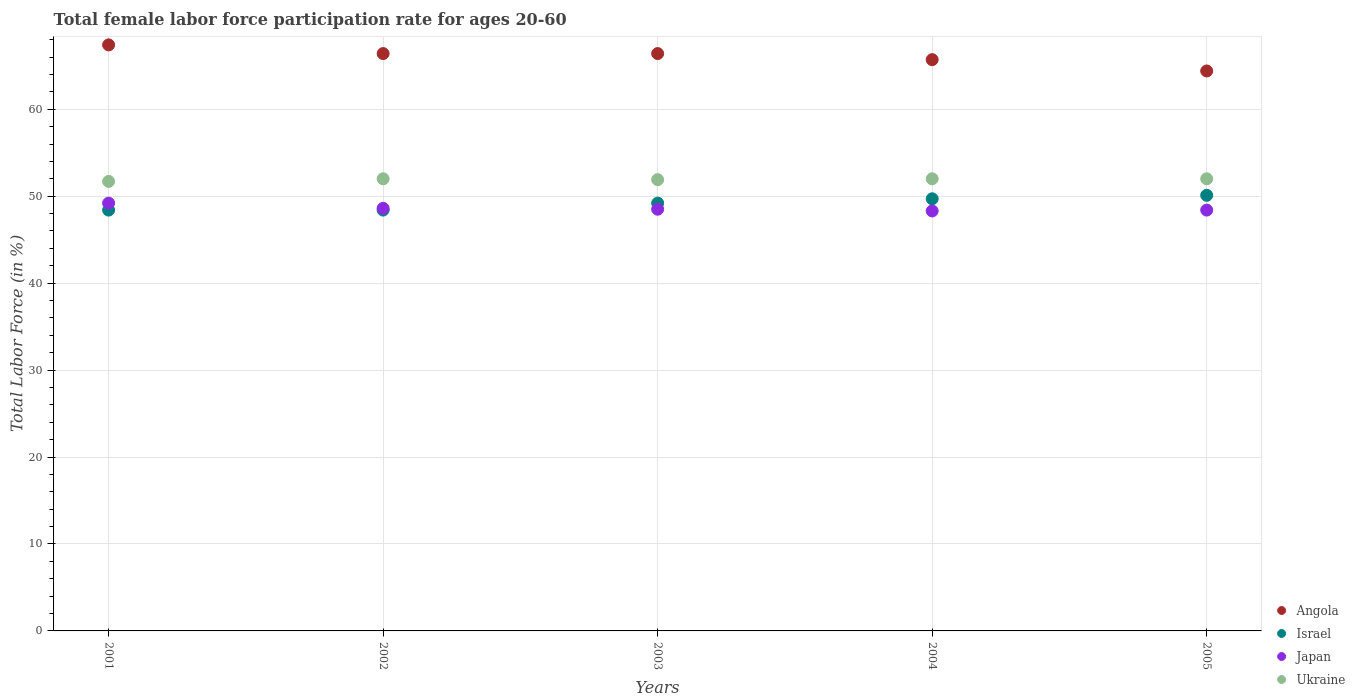How many different coloured dotlines are there?
Keep it short and to the point. 4. Is the number of dotlines equal to the number of legend labels?
Ensure brevity in your answer.  Yes. What is the female labor force participation rate in Angola in 2004?
Keep it short and to the point. 65.7. Across all years, what is the maximum female labor force participation rate in Angola?
Keep it short and to the point. 67.4. Across all years, what is the minimum female labor force participation rate in Japan?
Your response must be concise. 48.3. What is the total female labor force participation rate in Japan in the graph?
Give a very brief answer. 243. What is the average female labor force participation rate in Israel per year?
Keep it short and to the point. 49.16. In the year 2002, what is the difference between the female labor force participation rate in Israel and female labor force participation rate in Angola?
Offer a very short reply. -18. In how many years, is the female labor force participation rate in Israel greater than 60 %?
Your response must be concise. 0. What is the ratio of the female labor force participation rate in Israel in 2002 to that in 2004?
Keep it short and to the point. 0.97. Is the difference between the female labor force participation rate in Israel in 2004 and 2005 greater than the difference between the female labor force participation rate in Angola in 2004 and 2005?
Offer a terse response. No. What is the difference between the highest and the lowest female labor force participation rate in Ukraine?
Give a very brief answer. 0.3. In how many years, is the female labor force participation rate in Ukraine greater than the average female labor force participation rate in Ukraine taken over all years?
Offer a very short reply. 3. Is the sum of the female labor force participation rate in Angola in 2004 and 2005 greater than the maximum female labor force participation rate in Israel across all years?
Make the answer very short. Yes. Does the female labor force participation rate in Japan monotonically increase over the years?
Provide a succinct answer. No. Is the female labor force participation rate in Ukraine strictly greater than the female labor force participation rate in Angola over the years?
Keep it short and to the point. No. Does the graph contain any zero values?
Your answer should be very brief. No. How are the legend labels stacked?
Offer a terse response. Vertical. What is the title of the graph?
Give a very brief answer. Total female labor force participation rate for ages 20-60. Does "Monaco" appear as one of the legend labels in the graph?
Offer a terse response. No. What is the label or title of the Y-axis?
Provide a short and direct response. Total Labor Force (in %). What is the Total Labor Force (in %) of Angola in 2001?
Provide a short and direct response. 67.4. What is the Total Labor Force (in %) of Israel in 2001?
Give a very brief answer. 48.4. What is the Total Labor Force (in %) in Japan in 2001?
Give a very brief answer. 49.2. What is the Total Labor Force (in %) of Ukraine in 2001?
Your answer should be very brief. 51.7. What is the Total Labor Force (in %) in Angola in 2002?
Ensure brevity in your answer.  66.4. What is the Total Labor Force (in %) in Israel in 2002?
Keep it short and to the point. 48.4. What is the Total Labor Force (in %) of Japan in 2002?
Provide a succinct answer. 48.6. What is the Total Labor Force (in %) of Ukraine in 2002?
Your answer should be very brief. 52. What is the Total Labor Force (in %) in Angola in 2003?
Your response must be concise. 66.4. What is the Total Labor Force (in %) of Israel in 2003?
Your answer should be very brief. 49.2. What is the Total Labor Force (in %) in Japan in 2003?
Your response must be concise. 48.5. What is the Total Labor Force (in %) in Ukraine in 2003?
Provide a short and direct response. 51.9. What is the Total Labor Force (in %) in Angola in 2004?
Give a very brief answer. 65.7. What is the Total Labor Force (in %) of Israel in 2004?
Offer a very short reply. 49.7. What is the Total Labor Force (in %) in Japan in 2004?
Offer a terse response. 48.3. What is the Total Labor Force (in %) of Angola in 2005?
Offer a terse response. 64.4. What is the Total Labor Force (in %) of Israel in 2005?
Provide a short and direct response. 50.1. What is the Total Labor Force (in %) in Japan in 2005?
Offer a very short reply. 48.4. What is the Total Labor Force (in %) in Ukraine in 2005?
Offer a terse response. 52. Across all years, what is the maximum Total Labor Force (in %) of Angola?
Your answer should be compact. 67.4. Across all years, what is the maximum Total Labor Force (in %) in Israel?
Make the answer very short. 50.1. Across all years, what is the maximum Total Labor Force (in %) of Japan?
Make the answer very short. 49.2. Across all years, what is the minimum Total Labor Force (in %) of Angola?
Offer a terse response. 64.4. Across all years, what is the minimum Total Labor Force (in %) in Israel?
Offer a very short reply. 48.4. Across all years, what is the minimum Total Labor Force (in %) of Japan?
Keep it short and to the point. 48.3. Across all years, what is the minimum Total Labor Force (in %) in Ukraine?
Give a very brief answer. 51.7. What is the total Total Labor Force (in %) of Angola in the graph?
Keep it short and to the point. 330.3. What is the total Total Labor Force (in %) in Israel in the graph?
Give a very brief answer. 245.8. What is the total Total Labor Force (in %) of Japan in the graph?
Ensure brevity in your answer.  243. What is the total Total Labor Force (in %) in Ukraine in the graph?
Give a very brief answer. 259.6. What is the difference between the Total Labor Force (in %) of Japan in 2001 and that in 2002?
Offer a terse response. 0.6. What is the difference between the Total Labor Force (in %) of Ukraine in 2001 and that in 2002?
Make the answer very short. -0.3. What is the difference between the Total Labor Force (in %) in Angola in 2001 and that in 2003?
Provide a short and direct response. 1. What is the difference between the Total Labor Force (in %) in Japan in 2001 and that in 2003?
Keep it short and to the point. 0.7. What is the difference between the Total Labor Force (in %) in Angola in 2001 and that in 2004?
Your response must be concise. 1.7. What is the difference between the Total Labor Force (in %) in Israel in 2001 and that in 2004?
Your response must be concise. -1.3. What is the difference between the Total Labor Force (in %) in Ukraine in 2001 and that in 2004?
Provide a succinct answer. -0.3. What is the difference between the Total Labor Force (in %) of Angola in 2002 and that in 2003?
Your answer should be very brief. 0. What is the difference between the Total Labor Force (in %) in Israel in 2002 and that in 2003?
Your answer should be very brief. -0.8. What is the difference between the Total Labor Force (in %) in Ukraine in 2002 and that in 2003?
Your answer should be very brief. 0.1. What is the difference between the Total Labor Force (in %) of Angola in 2002 and that in 2004?
Keep it short and to the point. 0.7. What is the difference between the Total Labor Force (in %) in Japan in 2002 and that in 2004?
Your answer should be very brief. 0.3. What is the difference between the Total Labor Force (in %) of Ukraine in 2002 and that in 2004?
Make the answer very short. 0. What is the difference between the Total Labor Force (in %) in Israel in 2002 and that in 2005?
Provide a succinct answer. -1.7. What is the difference between the Total Labor Force (in %) in Ukraine in 2002 and that in 2005?
Offer a terse response. 0. What is the difference between the Total Labor Force (in %) in Israel in 2003 and that in 2004?
Your answer should be compact. -0.5. What is the difference between the Total Labor Force (in %) of Japan in 2003 and that in 2004?
Provide a short and direct response. 0.2. What is the difference between the Total Labor Force (in %) in Ukraine in 2003 and that in 2004?
Provide a succinct answer. -0.1. What is the difference between the Total Labor Force (in %) of Angola in 2004 and that in 2005?
Give a very brief answer. 1.3. What is the difference between the Total Labor Force (in %) of Angola in 2001 and the Total Labor Force (in %) of Japan in 2002?
Ensure brevity in your answer.  18.8. What is the difference between the Total Labor Force (in %) in Angola in 2001 and the Total Labor Force (in %) in Ukraine in 2002?
Provide a short and direct response. 15.4. What is the difference between the Total Labor Force (in %) of Israel in 2001 and the Total Labor Force (in %) of Ukraine in 2002?
Your response must be concise. -3.6. What is the difference between the Total Labor Force (in %) of Japan in 2001 and the Total Labor Force (in %) of Ukraine in 2002?
Provide a succinct answer. -2.8. What is the difference between the Total Labor Force (in %) in Angola in 2001 and the Total Labor Force (in %) in Ukraine in 2003?
Make the answer very short. 15.5. What is the difference between the Total Labor Force (in %) of Israel in 2001 and the Total Labor Force (in %) of Ukraine in 2003?
Provide a short and direct response. -3.5. What is the difference between the Total Labor Force (in %) in Japan in 2001 and the Total Labor Force (in %) in Ukraine in 2003?
Keep it short and to the point. -2.7. What is the difference between the Total Labor Force (in %) of Angola in 2001 and the Total Labor Force (in %) of Israel in 2004?
Offer a terse response. 17.7. What is the difference between the Total Labor Force (in %) of Angola in 2001 and the Total Labor Force (in %) of Ukraine in 2004?
Give a very brief answer. 15.4. What is the difference between the Total Labor Force (in %) in Japan in 2001 and the Total Labor Force (in %) in Ukraine in 2004?
Provide a short and direct response. -2.8. What is the difference between the Total Labor Force (in %) of Angola in 2001 and the Total Labor Force (in %) of Japan in 2005?
Give a very brief answer. 19. What is the difference between the Total Labor Force (in %) of Israel in 2001 and the Total Labor Force (in %) of Ukraine in 2005?
Give a very brief answer. -3.6. What is the difference between the Total Labor Force (in %) of Angola in 2002 and the Total Labor Force (in %) of Israel in 2003?
Offer a very short reply. 17.2. What is the difference between the Total Labor Force (in %) of Angola in 2002 and the Total Labor Force (in %) of Japan in 2003?
Offer a terse response. 17.9. What is the difference between the Total Labor Force (in %) in Angola in 2002 and the Total Labor Force (in %) in Ukraine in 2003?
Make the answer very short. 14.5. What is the difference between the Total Labor Force (in %) of Israel in 2002 and the Total Labor Force (in %) of Ukraine in 2003?
Your response must be concise. -3.5. What is the difference between the Total Labor Force (in %) in Japan in 2002 and the Total Labor Force (in %) in Ukraine in 2003?
Your answer should be compact. -3.3. What is the difference between the Total Labor Force (in %) of Israel in 2002 and the Total Labor Force (in %) of Japan in 2004?
Offer a terse response. 0.1. What is the difference between the Total Labor Force (in %) in Israel in 2002 and the Total Labor Force (in %) in Ukraine in 2004?
Your response must be concise. -3.6. What is the difference between the Total Labor Force (in %) in Angola in 2002 and the Total Labor Force (in %) in Japan in 2005?
Your response must be concise. 18. What is the difference between the Total Labor Force (in %) in Angola in 2002 and the Total Labor Force (in %) in Ukraine in 2005?
Ensure brevity in your answer.  14.4. What is the difference between the Total Labor Force (in %) of Israel in 2002 and the Total Labor Force (in %) of Japan in 2005?
Make the answer very short. 0. What is the difference between the Total Labor Force (in %) of Angola in 2003 and the Total Labor Force (in %) of Israel in 2004?
Your response must be concise. 16.7. What is the difference between the Total Labor Force (in %) of Angola in 2003 and the Total Labor Force (in %) of Japan in 2004?
Provide a short and direct response. 18.1. What is the difference between the Total Labor Force (in %) of Angola in 2003 and the Total Labor Force (in %) of Ukraine in 2004?
Provide a succinct answer. 14.4. What is the difference between the Total Labor Force (in %) in Japan in 2003 and the Total Labor Force (in %) in Ukraine in 2004?
Keep it short and to the point. -3.5. What is the difference between the Total Labor Force (in %) of Angola in 2003 and the Total Labor Force (in %) of Japan in 2005?
Give a very brief answer. 18. What is the difference between the Total Labor Force (in %) in Angola in 2003 and the Total Labor Force (in %) in Ukraine in 2005?
Offer a terse response. 14.4. What is the difference between the Total Labor Force (in %) in Israel in 2003 and the Total Labor Force (in %) in Japan in 2005?
Offer a terse response. 0.8. What is the difference between the Total Labor Force (in %) in Angola in 2004 and the Total Labor Force (in %) in Japan in 2005?
Provide a succinct answer. 17.3. What is the difference between the Total Labor Force (in %) of Angola in 2004 and the Total Labor Force (in %) of Ukraine in 2005?
Provide a succinct answer. 13.7. What is the difference between the Total Labor Force (in %) of Israel in 2004 and the Total Labor Force (in %) of Japan in 2005?
Your answer should be compact. 1.3. What is the average Total Labor Force (in %) of Angola per year?
Make the answer very short. 66.06. What is the average Total Labor Force (in %) in Israel per year?
Your answer should be very brief. 49.16. What is the average Total Labor Force (in %) in Japan per year?
Your answer should be very brief. 48.6. What is the average Total Labor Force (in %) in Ukraine per year?
Provide a succinct answer. 51.92. In the year 2001, what is the difference between the Total Labor Force (in %) of Angola and Total Labor Force (in %) of Israel?
Offer a terse response. 19. In the year 2001, what is the difference between the Total Labor Force (in %) of Angola and Total Labor Force (in %) of Japan?
Provide a short and direct response. 18.2. In the year 2001, what is the difference between the Total Labor Force (in %) in Israel and Total Labor Force (in %) in Japan?
Offer a terse response. -0.8. In the year 2001, what is the difference between the Total Labor Force (in %) in Israel and Total Labor Force (in %) in Ukraine?
Give a very brief answer. -3.3. In the year 2001, what is the difference between the Total Labor Force (in %) in Japan and Total Labor Force (in %) in Ukraine?
Keep it short and to the point. -2.5. In the year 2002, what is the difference between the Total Labor Force (in %) of Angola and Total Labor Force (in %) of Israel?
Your answer should be compact. 18. In the year 2002, what is the difference between the Total Labor Force (in %) of Angola and Total Labor Force (in %) of Ukraine?
Provide a short and direct response. 14.4. In the year 2002, what is the difference between the Total Labor Force (in %) in Israel and Total Labor Force (in %) in Japan?
Ensure brevity in your answer.  -0.2. In the year 2002, what is the difference between the Total Labor Force (in %) in Israel and Total Labor Force (in %) in Ukraine?
Provide a short and direct response. -3.6. In the year 2002, what is the difference between the Total Labor Force (in %) in Japan and Total Labor Force (in %) in Ukraine?
Offer a terse response. -3.4. In the year 2003, what is the difference between the Total Labor Force (in %) of Angola and Total Labor Force (in %) of Israel?
Offer a very short reply. 17.2. In the year 2003, what is the difference between the Total Labor Force (in %) of Angola and Total Labor Force (in %) of Japan?
Provide a short and direct response. 17.9. In the year 2003, what is the difference between the Total Labor Force (in %) in Angola and Total Labor Force (in %) in Ukraine?
Give a very brief answer. 14.5. In the year 2003, what is the difference between the Total Labor Force (in %) of Israel and Total Labor Force (in %) of Japan?
Give a very brief answer. 0.7. In the year 2003, what is the difference between the Total Labor Force (in %) in Israel and Total Labor Force (in %) in Ukraine?
Your response must be concise. -2.7. In the year 2003, what is the difference between the Total Labor Force (in %) in Japan and Total Labor Force (in %) in Ukraine?
Ensure brevity in your answer.  -3.4. In the year 2004, what is the difference between the Total Labor Force (in %) of Angola and Total Labor Force (in %) of Japan?
Make the answer very short. 17.4. In the year 2005, what is the difference between the Total Labor Force (in %) of Angola and Total Labor Force (in %) of Ukraine?
Your response must be concise. 12.4. In the year 2005, what is the difference between the Total Labor Force (in %) of Israel and Total Labor Force (in %) of Japan?
Your answer should be compact. 1.7. In the year 2005, what is the difference between the Total Labor Force (in %) of Israel and Total Labor Force (in %) of Ukraine?
Your answer should be very brief. -1.9. In the year 2005, what is the difference between the Total Labor Force (in %) of Japan and Total Labor Force (in %) of Ukraine?
Provide a succinct answer. -3.6. What is the ratio of the Total Labor Force (in %) in Angola in 2001 to that in 2002?
Make the answer very short. 1.02. What is the ratio of the Total Labor Force (in %) in Israel in 2001 to that in 2002?
Your response must be concise. 1. What is the ratio of the Total Labor Force (in %) in Japan in 2001 to that in 2002?
Your answer should be very brief. 1.01. What is the ratio of the Total Labor Force (in %) of Angola in 2001 to that in 2003?
Your answer should be very brief. 1.02. What is the ratio of the Total Labor Force (in %) in Israel in 2001 to that in 2003?
Give a very brief answer. 0.98. What is the ratio of the Total Labor Force (in %) in Japan in 2001 to that in 2003?
Make the answer very short. 1.01. What is the ratio of the Total Labor Force (in %) in Ukraine in 2001 to that in 2003?
Give a very brief answer. 1. What is the ratio of the Total Labor Force (in %) in Angola in 2001 to that in 2004?
Make the answer very short. 1.03. What is the ratio of the Total Labor Force (in %) in Israel in 2001 to that in 2004?
Give a very brief answer. 0.97. What is the ratio of the Total Labor Force (in %) in Japan in 2001 to that in 2004?
Your answer should be compact. 1.02. What is the ratio of the Total Labor Force (in %) of Ukraine in 2001 to that in 2004?
Your answer should be very brief. 0.99. What is the ratio of the Total Labor Force (in %) of Angola in 2001 to that in 2005?
Provide a succinct answer. 1.05. What is the ratio of the Total Labor Force (in %) in Israel in 2001 to that in 2005?
Ensure brevity in your answer.  0.97. What is the ratio of the Total Labor Force (in %) of Japan in 2001 to that in 2005?
Give a very brief answer. 1.02. What is the ratio of the Total Labor Force (in %) in Israel in 2002 to that in 2003?
Keep it short and to the point. 0.98. What is the ratio of the Total Labor Force (in %) in Japan in 2002 to that in 2003?
Keep it short and to the point. 1. What is the ratio of the Total Labor Force (in %) in Angola in 2002 to that in 2004?
Provide a short and direct response. 1.01. What is the ratio of the Total Labor Force (in %) of Israel in 2002 to that in 2004?
Ensure brevity in your answer.  0.97. What is the ratio of the Total Labor Force (in %) in Ukraine in 2002 to that in 2004?
Provide a succinct answer. 1. What is the ratio of the Total Labor Force (in %) in Angola in 2002 to that in 2005?
Offer a very short reply. 1.03. What is the ratio of the Total Labor Force (in %) in Israel in 2002 to that in 2005?
Your answer should be very brief. 0.97. What is the ratio of the Total Labor Force (in %) of Japan in 2002 to that in 2005?
Provide a short and direct response. 1. What is the ratio of the Total Labor Force (in %) in Angola in 2003 to that in 2004?
Your response must be concise. 1.01. What is the ratio of the Total Labor Force (in %) of Japan in 2003 to that in 2004?
Ensure brevity in your answer.  1. What is the ratio of the Total Labor Force (in %) in Ukraine in 2003 to that in 2004?
Your answer should be compact. 1. What is the ratio of the Total Labor Force (in %) of Angola in 2003 to that in 2005?
Keep it short and to the point. 1.03. What is the ratio of the Total Labor Force (in %) in Angola in 2004 to that in 2005?
Provide a short and direct response. 1.02. What is the ratio of the Total Labor Force (in %) of Japan in 2004 to that in 2005?
Your answer should be very brief. 1. What is the difference between the highest and the second highest Total Labor Force (in %) in Angola?
Ensure brevity in your answer.  1. What is the difference between the highest and the second highest Total Labor Force (in %) in Japan?
Give a very brief answer. 0.6. 